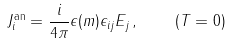Convert formula to latex. <formula><loc_0><loc_0><loc_500><loc_500>J _ { i } ^ { \text {an} } = \frac { i } { 4 \pi } \epsilon ( m ) \epsilon _ { i j } E _ { j } \, , \quad ( T = 0 ) \,</formula> 